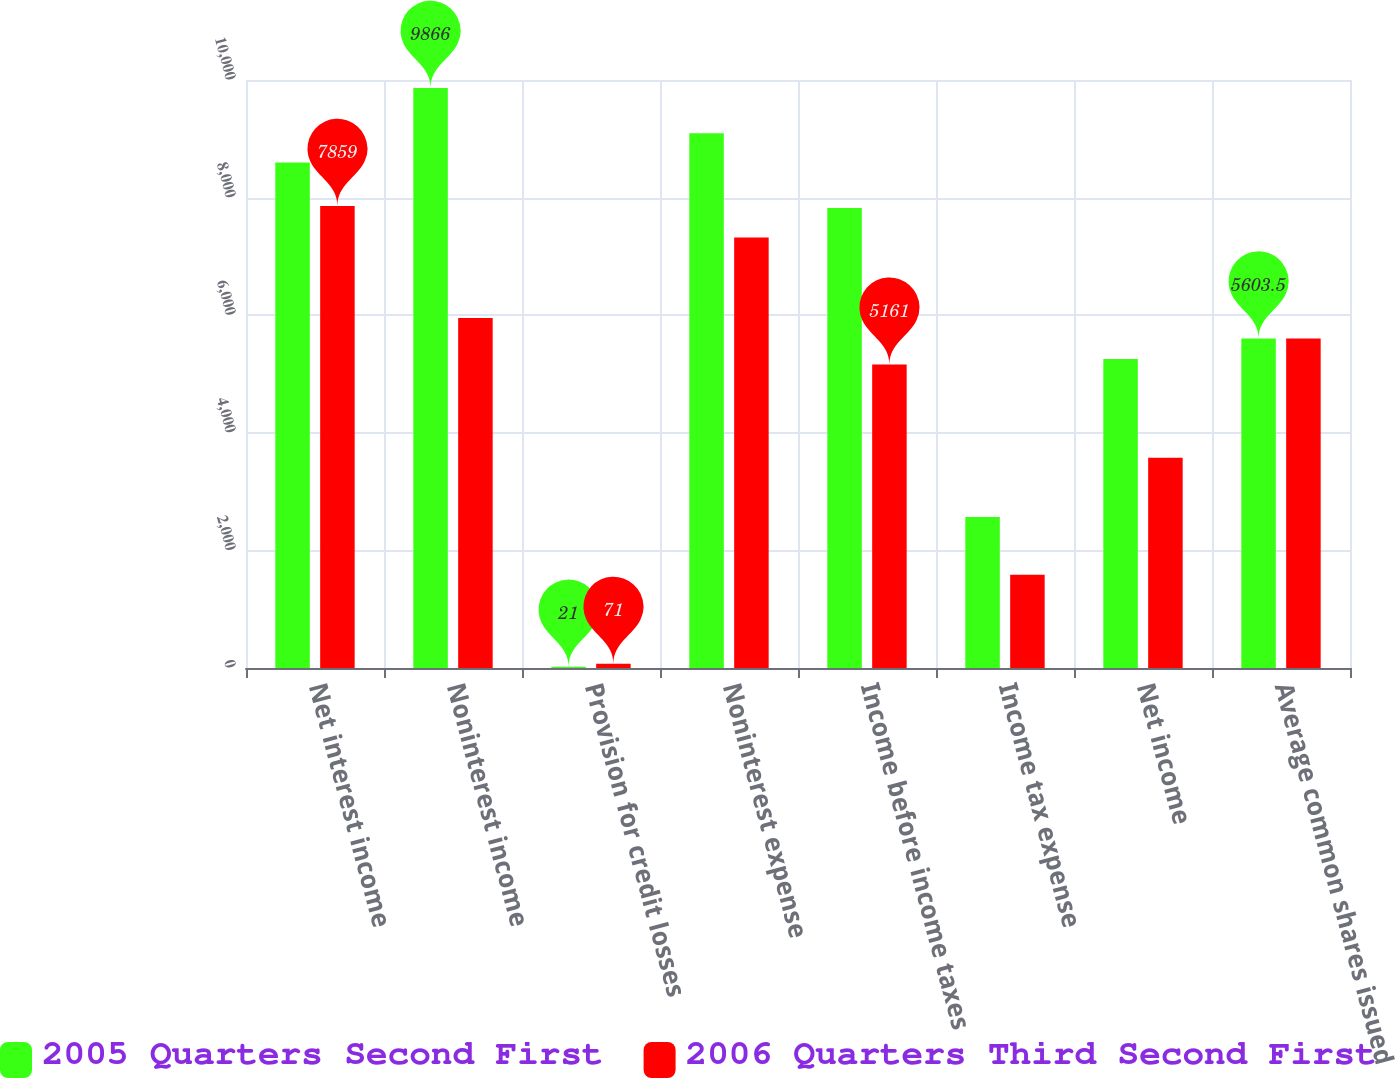Convert chart. <chart><loc_0><loc_0><loc_500><loc_500><stacked_bar_chart><ecel><fcel>Net interest income<fcel>Noninterest income<fcel>Provision for credit losses<fcel>Noninterest expense<fcel>Income before income taxes<fcel>Income tax expense<fcel>Net income<fcel>Average common shares issued<nl><fcel>2005 Quarters Second First<fcel>8599<fcel>9866<fcel>21<fcel>9093<fcel>7823<fcel>2567<fcel>5256<fcel>5603.5<nl><fcel>2006 Quarters Third Second First<fcel>7859<fcel>5951<fcel>71<fcel>7320<fcel>5161<fcel>1587<fcel>3574<fcel>5603.5<nl></chart> 